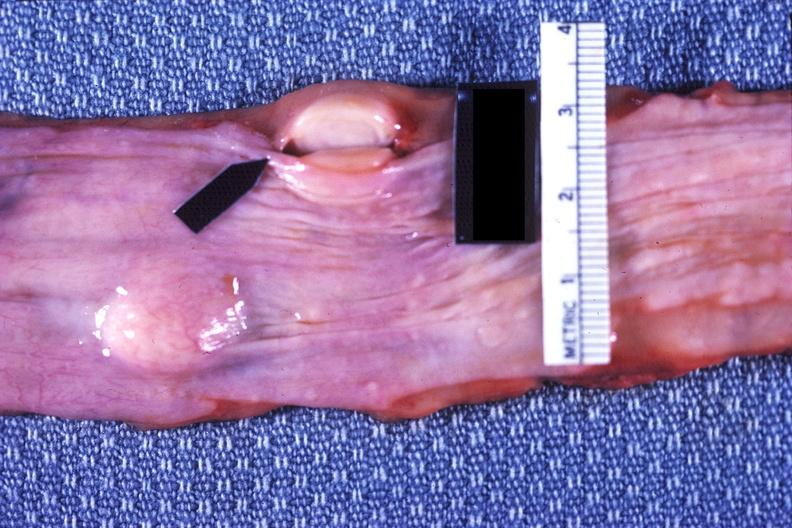does this image show esophagus, leiomyoma?
Answer the question using a single word or phrase. Yes 